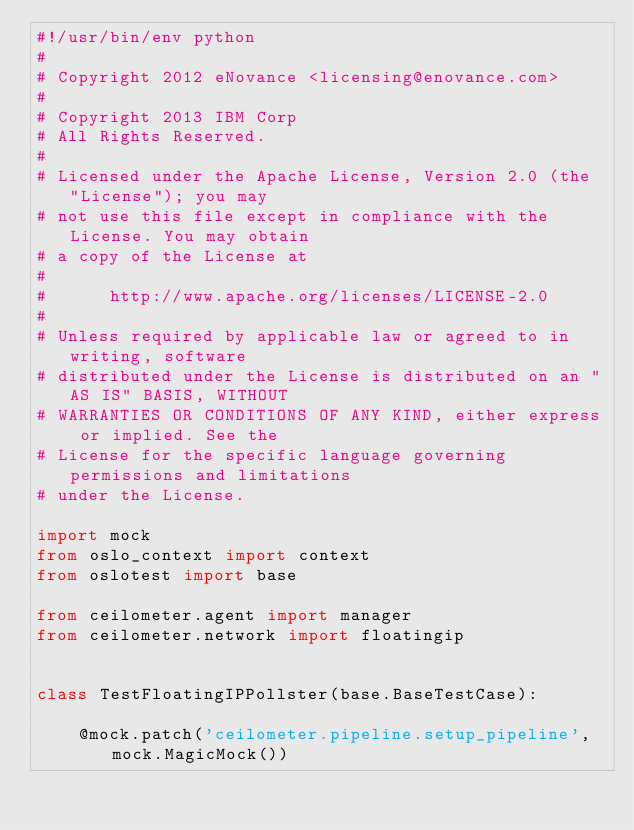<code> <loc_0><loc_0><loc_500><loc_500><_Python_>#!/usr/bin/env python
#
# Copyright 2012 eNovance <licensing@enovance.com>
#
# Copyright 2013 IBM Corp
# All Rights Reserved.
#
# Licensed under the Apache License, Version 2.0 (the "License"); you may
# not use this file except in compliance with the License. You may obtain
# a copy of the License at
#
#      http://www.apache.org/licenses/LICENSE-2.0
#
# Unless required by applicable law or agreed to in writing, software
# distributed under the License is distributed on an "AS IS" BASIS, WITHOUT
# WARRANTIES OR CONDITIONS OF ANY KIND, either express or implied. See the
# License for the specific language governing permissions and limitations
# under the License.

import mock
from oslo_context import context
from oslotest import base

from ceilometer.agent import manager
from ceilometer.network import floatingip


class TestFloatingIPPollster(base.BaseTestCase):

    @mock.patch('ceilometer.pipeline.setup_pipeline', mock.MagicMock())</code> 